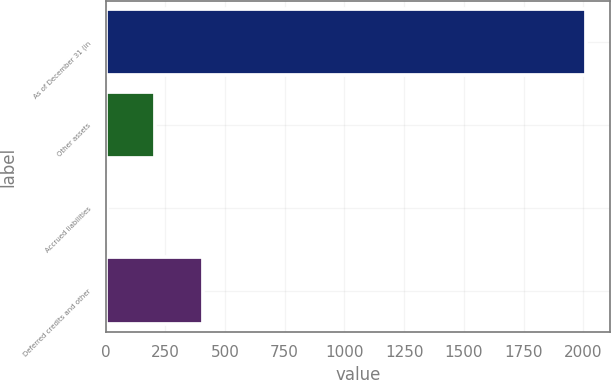<chart> <loc_0><loc_0><loc_500><loc_500><bar_chart><fcel>As of December 31 (in<fcel>Other assets<fcel>Accrued liabilities<fcel>Deferred credits and other<nl><fcel>2011<fcel>205.6<fcel>5<fcel>406.2<nl></chart> 